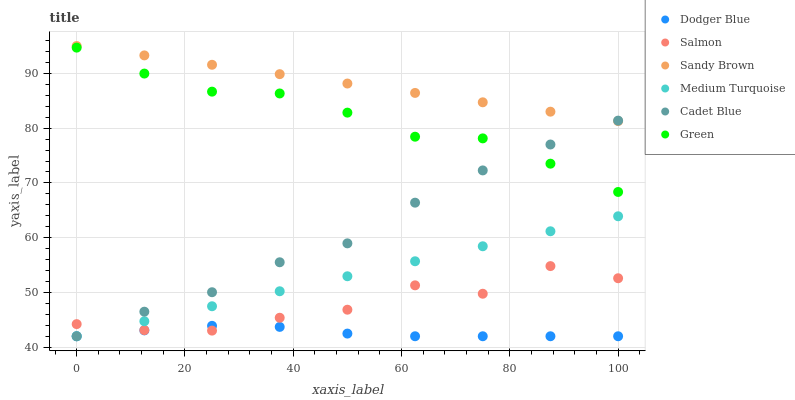Does Dodger Blue have the minimum area under the curve?
Answer yes or no. Yes. Does Sandy Brown have the maximum area under the curve?
Answer yes or no. Yes. Does Salmon have the minimum area under the curve?
Answer yes or no. No. Does Salmon have the maximum area under the curve?
Answer yes or no. No. Is Sandy Brown the smoothest?
Answer yes or no. Yes. Is Salmon the roughest?
Answer yes or no. Yes. Is Green the smoothest?
Answer yes or no. No. Is Green the roughest?
Answer yes or no. No. Does Cadet Blue have the lowest value?
Answer yes or no. Yes. Does Salmon have the lowest value?
Answer yes or no. No. Does Sandy Brown have the highest value?
Answer yes or no. Yes. Does Salmon have the highest value?
Answer yes or no. No. Is Green less than Sandy Brown?
Answer yes or no. Yes. Is Sandy Brown greater than Medium Turquoise?
Answer yes or no. Yes. Does Cadet Blue intersect Salmon?
Answer yes or no. Yes. Is Cadet Blue less than Salmon?
Answer yes or no. No. Is Cadet Blue greater than Salmon?
Answer yes or no. No. Does Green intersect Sandy Brown?
Answer yes or no. No. 